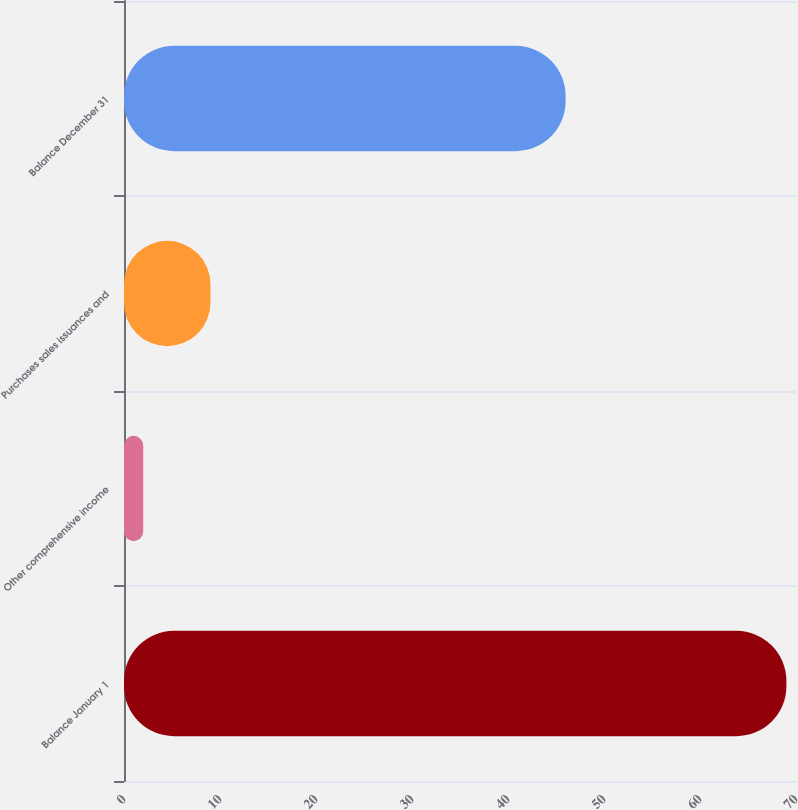Convert chart to OTSL. <chart><loc_0><loc_0><loc_500><loc_500><bar_chart><fcel>Balance January 1<fcel>Other comprehensive income<fcel>Purchases sales issuances and<fcel>Balance December 31<nl><fcel>69<fcel>2<fcel>9<fcel>46<nl></chart> 